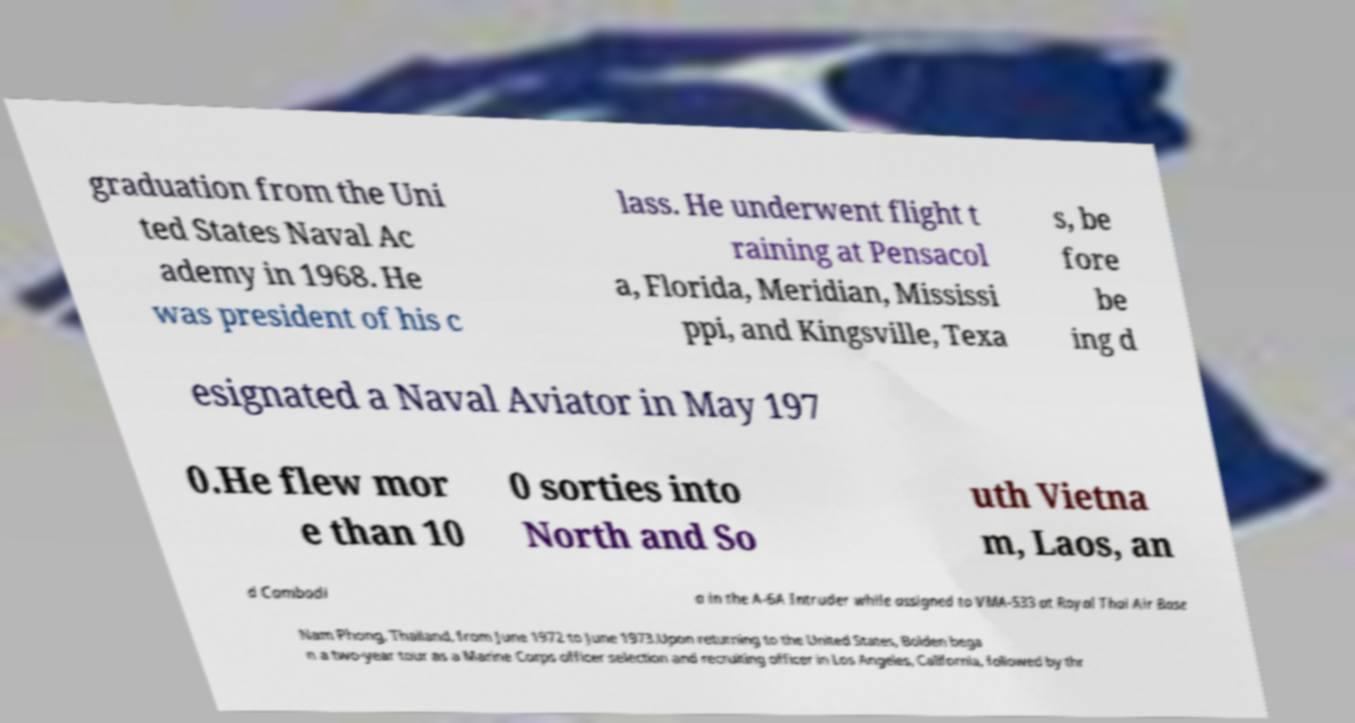For documentation purposes, I need the text within this image transcribed. Could you provide that? graduation from the Uni ted States Naval Ac ademy in 1968. He was president of his c lass. He underwent flight t raining at Pensacol a, Florida, Meridian, Mississi ppi, and Kingsville, Texa s, be fore be ing d esignated a Naval Aviator in May 197 0.He flew mor e than 10 0 sorties into North and So uth Vietna m, Laos, an d Cambodi a in the A-6A Intruder while assigned to VMA-533 at Royal Thai Air Base Nam Phong, Thailand, from June 1972 to June 1973.Upon returning to the United States, Bolden bega n a two-year tour as a Marine Corps officer selection and recruiting officer in Los Angeles, California, followed by thr 